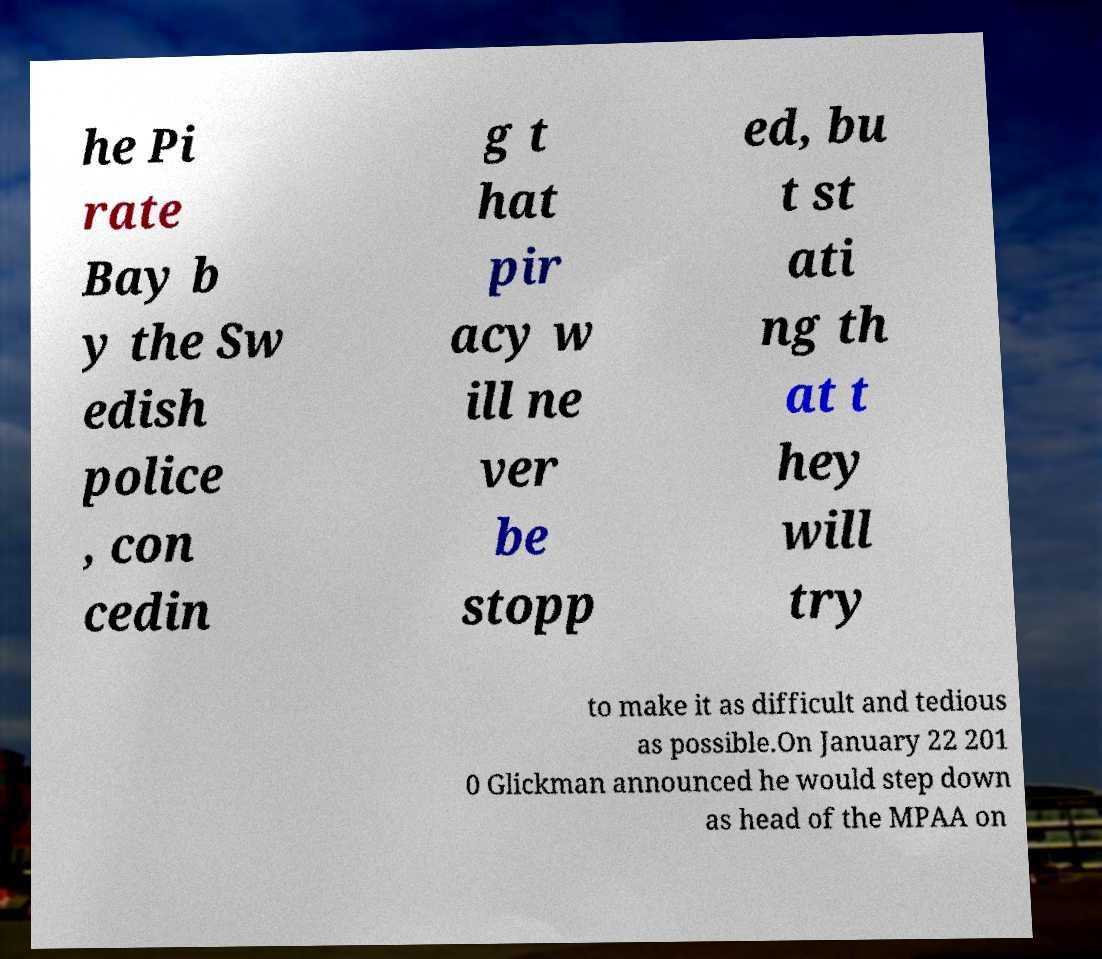Can you accurately transcribe the text from the provided image for me? he Pi rate Bay b y the Sw edish police , con cedin g t hat pir acy w ill ne ver be stopp ed, bu t st ati ng th at t hey will try to make it as difficult and tedious as possible.On January 22 201 0 Glickman announced he would step down as head of the MPAA on 